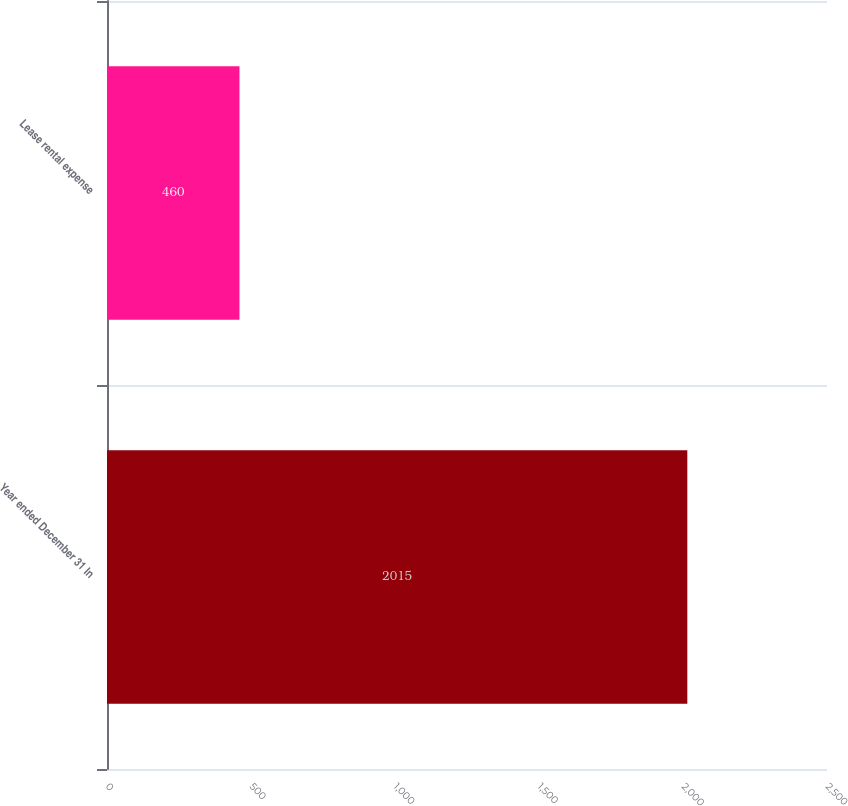Convert chart. <chart><loc_0><loc_0><loc_500><loc_500><bar_chart><fcel>Year ended December 31 In<fcel>Lease rental expense<nl><fcel>2015<fcel>460<nl></chart> 